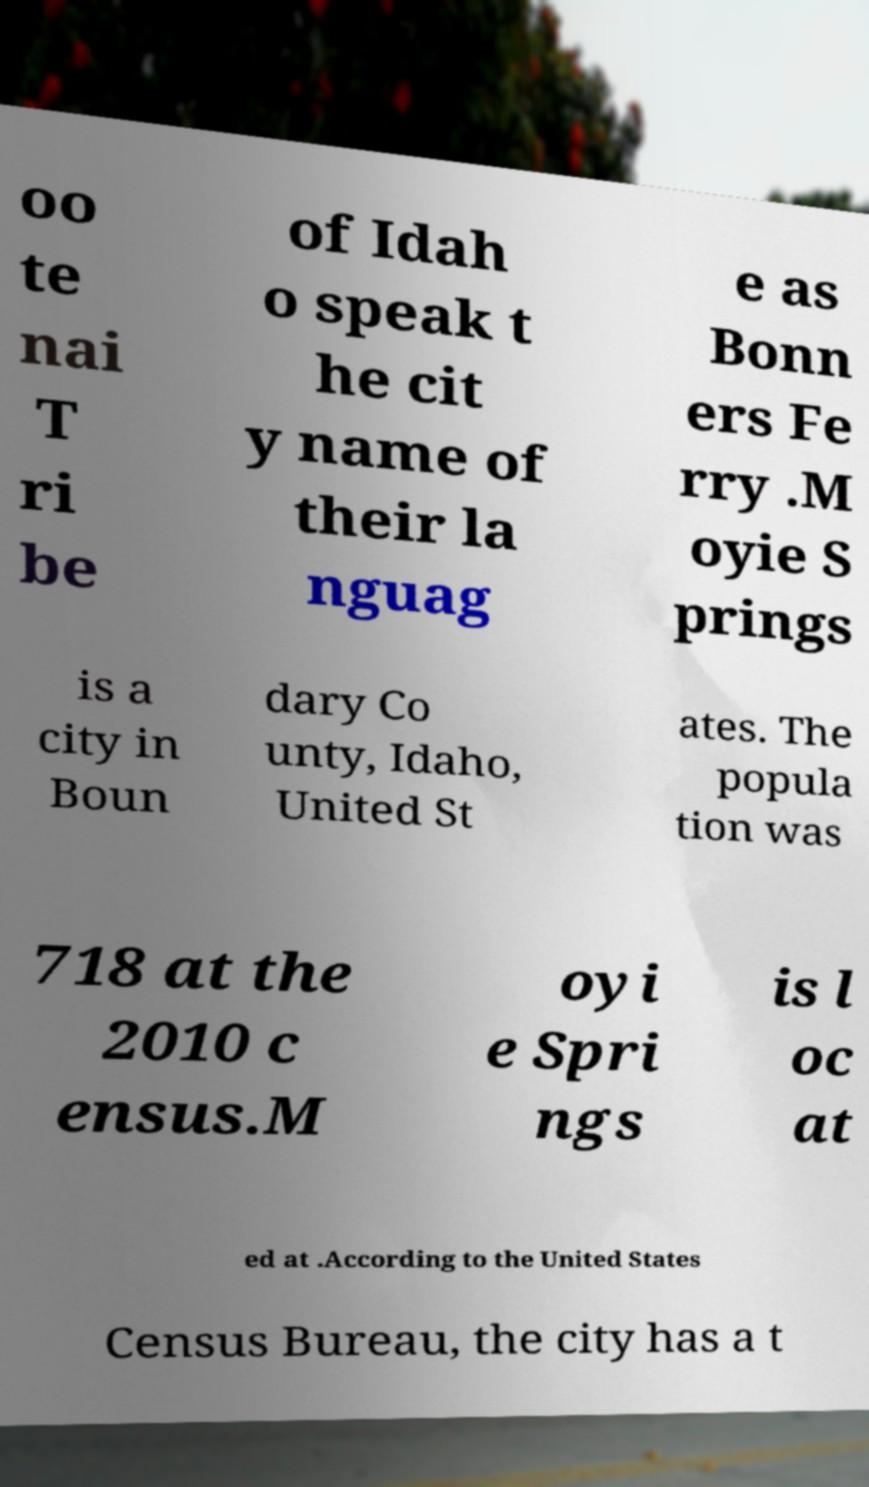Could you assist in decoding the text presented in this image and type it out clearly? oo te nai T ri be of Idah o speak t he cit y name of their la nguag e as Bonn ers Fe rry .M oyie S prings is a city in Boun dary Co unty, Idaho, United St ates. The popula tion was 718 at the 2010 c ensus.M oyi e Spri ngs is l oc at ed at .According to the United States Census Bureau, the city has a t 